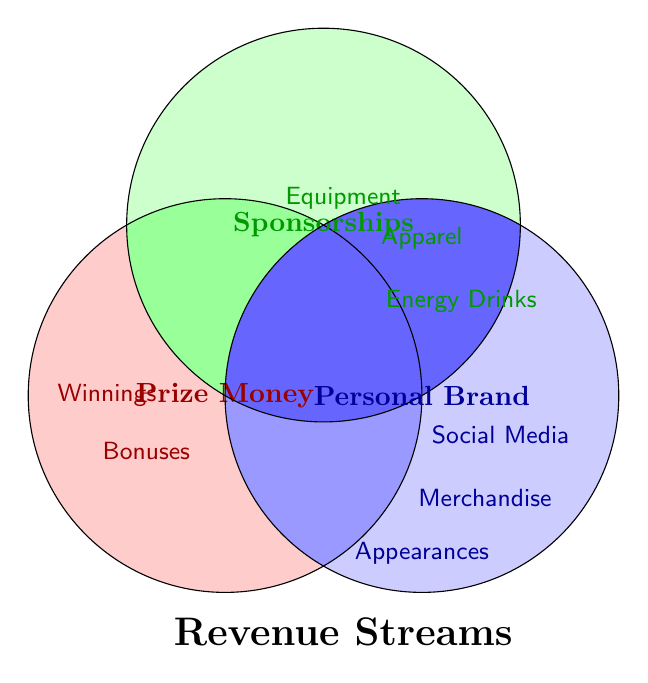Which category offers bonuses? The "Prize Money" circle includes "Championship Bonuses", identifiable by its position inside the red-colored section of the Venn Diagram.
Answer: Prize Money What types of partnerships fall under Sponsorships? The "Sponsorships" circle contains "Equipment Deals", "Apparel Endorsements", and "Energy Drink Partnerships", all positioned within the green-colored section of the Venn Diagram.
Answer: Equipment Deals, Apparel Endorsements, Energy Drink Partnerships How many revenue streams are linked to the Personal Brand category? The "Personal Brand" circle includes "Social Media Collaborations", "Merchandise Sales", and "Appearance Fees", totaling three revenue streams within the blue-colored section of the Venn Diagram.
Answer: 3 Which categories, if any, overlap in the diagram? The centered position of "Revenue Streams" without any overlapping portions suggests no overlaps among the categories ("Prize Money", "Sponsorships", "Personal Brand") in this Venn Diagram.
Answer: None Compare the number of revenue streams between Prize Money and Sponsorships. Which has more? Prize Money contains "Race Winnings" and "Championship Bonuses" (2 streams), while Sponsorships includes "Equipment Deals", "Apparel Endorsements", and "Energy Drink Partnerships" (3 streams). Sponsorships have more streams.
Answer: Sponsorships Which category includes earnings from race events? The "Prize Money" circle, highlighted in red, includes "Race Winnings", indicating that earnings from race events fall under this category.
Answer: Prize Money What forms of income come directly from a rider's fame or presence? The "Personal Brand" circle contains "Social Media Collaborations", "Merchandise Sales", and "Appearance Fees", all of which are driven by the rider's fame or presence.
Answer: Social Media Collaborations, Merchandise Sales, Appearance Fees 